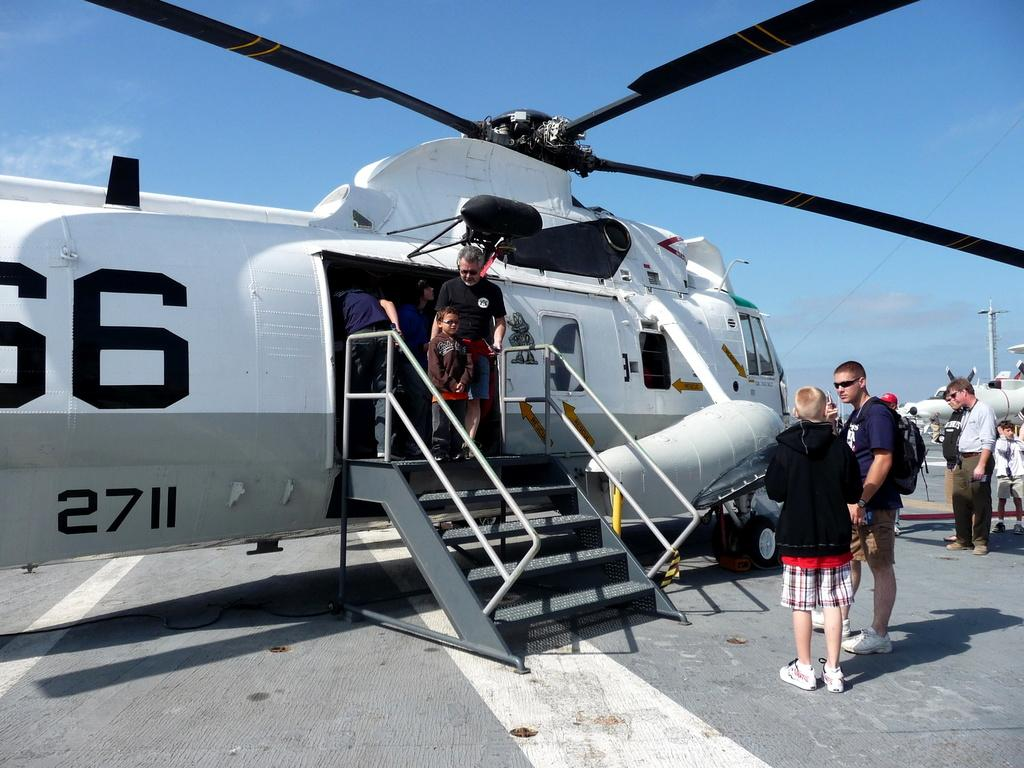What is the main subject of the image? The main subject of the image is an aircraft. Are there any people visible in the image? Yes, there are people in the image. What can be seen in the background of the image? There are clouds in the sky in the background of the image. What type of joke is being told by the clouds in the image? There is no joke being told by the clouds in the image; they are simply visible in the sky. 